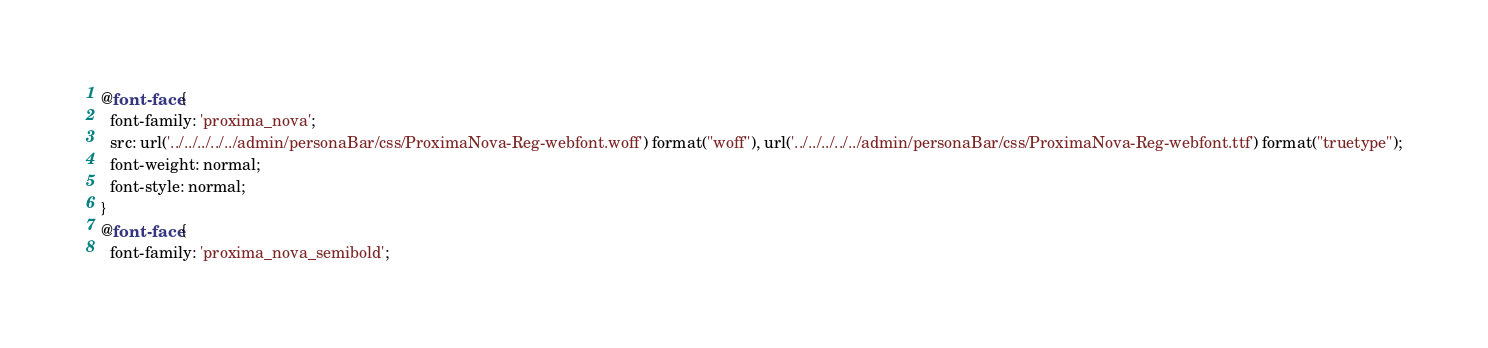Convert code to text. <code><loc_0><loc_0><loc_500><loc_500><_CSS_>@font-face {
  font-family: 'proxima_nova';
  src: url('../../../../../admin/personaBar/css/ProximaNova-Reg-webfont.woff') format("woff"), url('../../../../../admin/personaBar/css/ProximaNova-Reg-webfont.ttf') format("truetype");
  font-weight: normal;
  font-style: normal;
}
@font-face {
  font-family: 'proxima_nova_semibold';</code> 